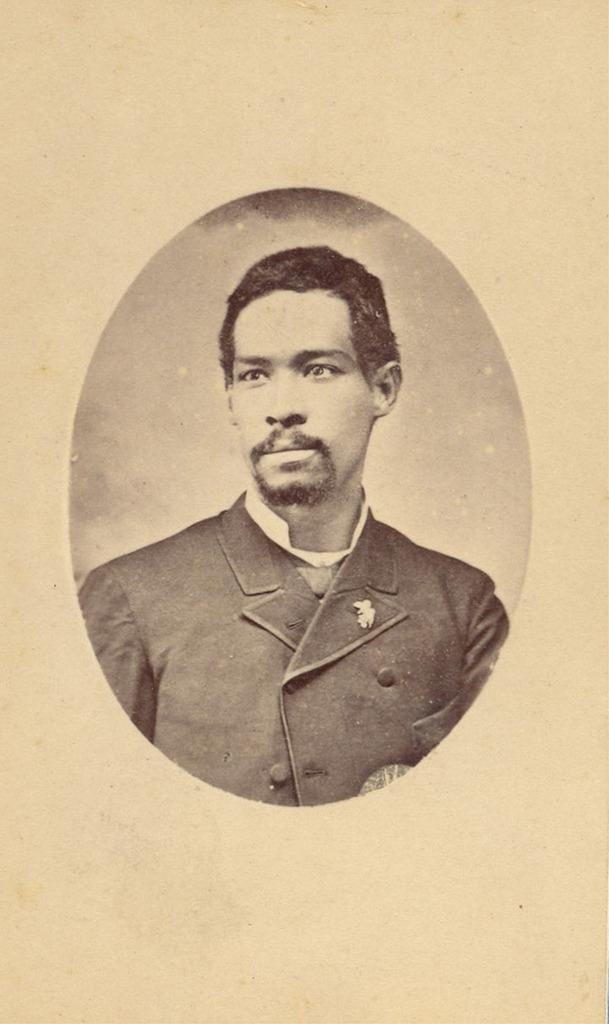What type of photo is in the image? The image contains a passport size photo of a man. What is the color scheme of the photo? The image is black and white. What is the man in the photo wearing? The man in the photo is wearing a coat. What type of vessel can be seen in the background of the photo? There is no vessel or background visible in the photo, as it is a passport size photo of a man wearing a coat. 